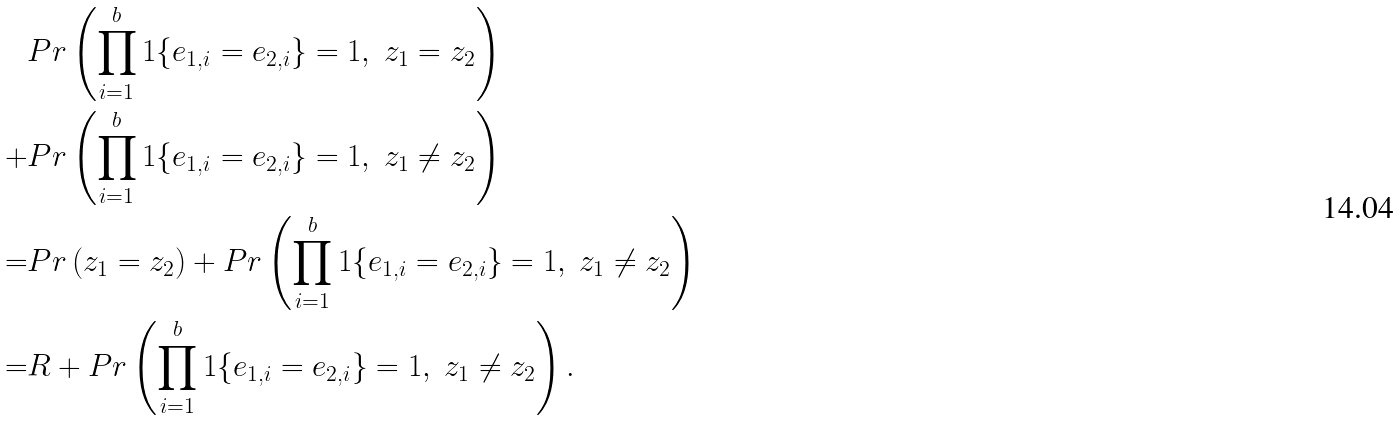<formula> <loc_0><loc_0><loc_500><loc_500>& P r \left ( \prod _ { i = 1 } ^ { b } 1 \{ e _ { 1 , i } = e _ { 2 , i } \} = 1 , \ z _ { 1 } = z _ { 2 } \right ) \\ + & P r \left ( \prod _ { i = 1 } ^ { b } 1 \{ e _ { 1 , i } = e _ { 2 , i } \} = 1 , \ z _ { 1 } \neq z _ { 2 } \right ) \\ = & P r \left ( z _ { 1 } = z _ { 2 } \right ) + P r \left ( \prod _ { i = 1 } ^ { b } 1 \{ e _ { 1 , i } = e _ { 2 , i } \} = 1 , \ z _ { 1 } \neq z _ { 2 } \right ) \\ = & R + P r \left ( \prod _ { i = 1 } ^ { b } 1 \{ e _ { 1 , i } = e _ { 2 , i } \} = 1 , \ z _ { 1 } \neq z _ { 2 } \right ) .</formula> 